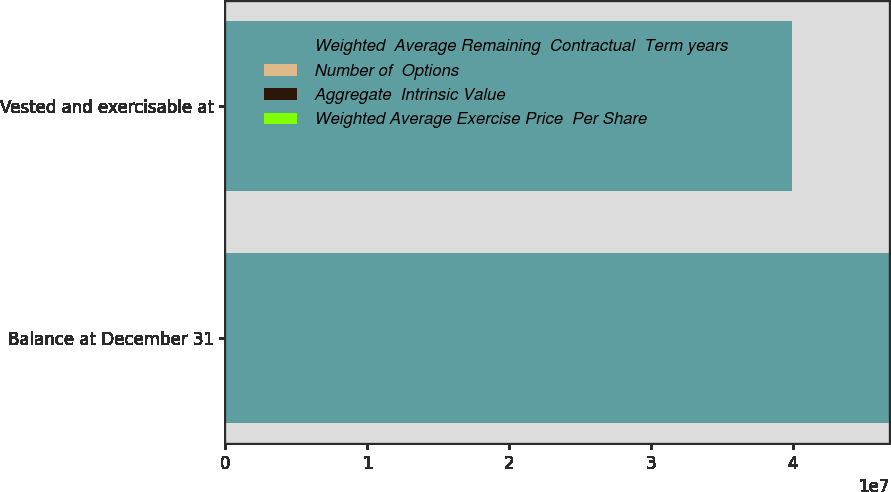Convert chart to OTSL. <chart><loc_0><loc_0><loc_500><loc_500><stacked_bar_chart><ecel><fcel>Balance at December 31<fcel>Vested and exercisable at<nl><fcel>Weighted  Average Remaining  Contractual  Term years<fcel>4.68064e+07<fcel>3.99199e+07<nl><fcel>Number of  Options<fcel>27.4<fcel>29.8<nl><fcel>Aggregate  Intrinsic Value<fcel>4.5<fcel>3.8<nl><fcel>Weighted Average Exercise Price  Per Share<fcel>38<fcel>26<nl></chart> 